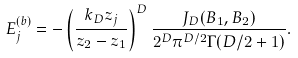Convert formula to latex. <formula><loc_0><loc_0><loc_500><loc_500>E _ { j } ^ { ( b ) } = - \left ( \frac { k _ { D } z _ { j } } { z _ { 2 } - z _ { 1 } } \right ) ^ { D } \frac { J _ { D } ( B _ { 1 } , B _ { 2 } ) } { 2 ^ { D } \pi ^ { D / 2 } \Gamma ( D / 2 + 1 ) } .</formula> 